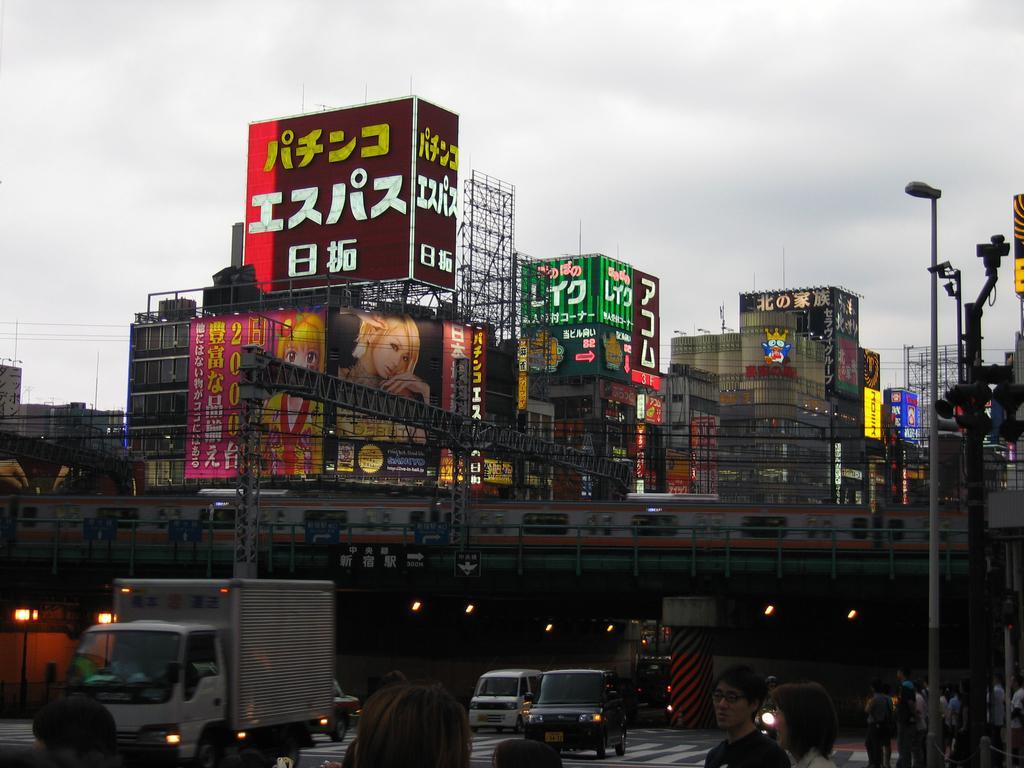In one or two sentences, can you explain what this image depicts? At the bottom I can see a crowd, vehicles on the road, light poles, bridge, metal rods and a train. In the background I can see buildings, hoardings, boards and the sky. This image is taken may be on the road. 